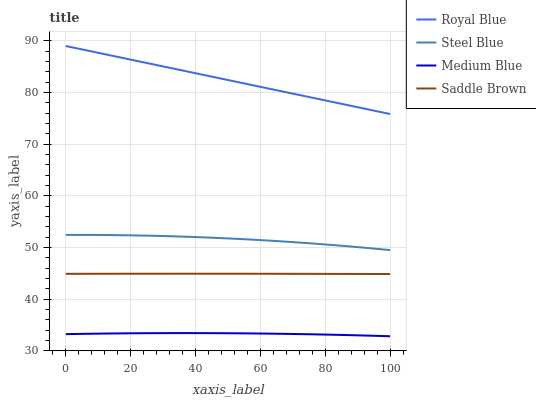Does Medium Blue have the minimum area under the curve?
Answer yes or no. Yes. Does Royal Blue have the maximum area under the curve?
Answer yes or no. Yes. Does Steel Blue have the minimum area under the curve?
Answer yes or no. No. Does Steel Blue have the maximum area under the curve?
Answer yes or no. No. Is Royal Blue the smoothest?
Answer yes or no. Yes. Is Steel Blue the roughest?
Answer yes or no. Yes. Is Medium Blue the smoothest?
Answer yes or no. No. Is Medium Blue the roughest?
Answer yes or no. No. Does Medium Blue have the lowest value?
Answer yes or no. Yes. Does Steel Blue have the lowest value?
Answer yes or no. No. Does Royal Blue have the highest value?
Answer yes or no. Yes. Does Steel Blue have the highest value?
Answer yes or no. No. Is Saddle Brown less than Steel Blue?
Answer yes or no. Yes. Is Royal Blue greater than Saddle Brown?
Answer yes or no. Yes. Does Saddle Brown intersect Steel Blue?
Answer yes or no. No. 